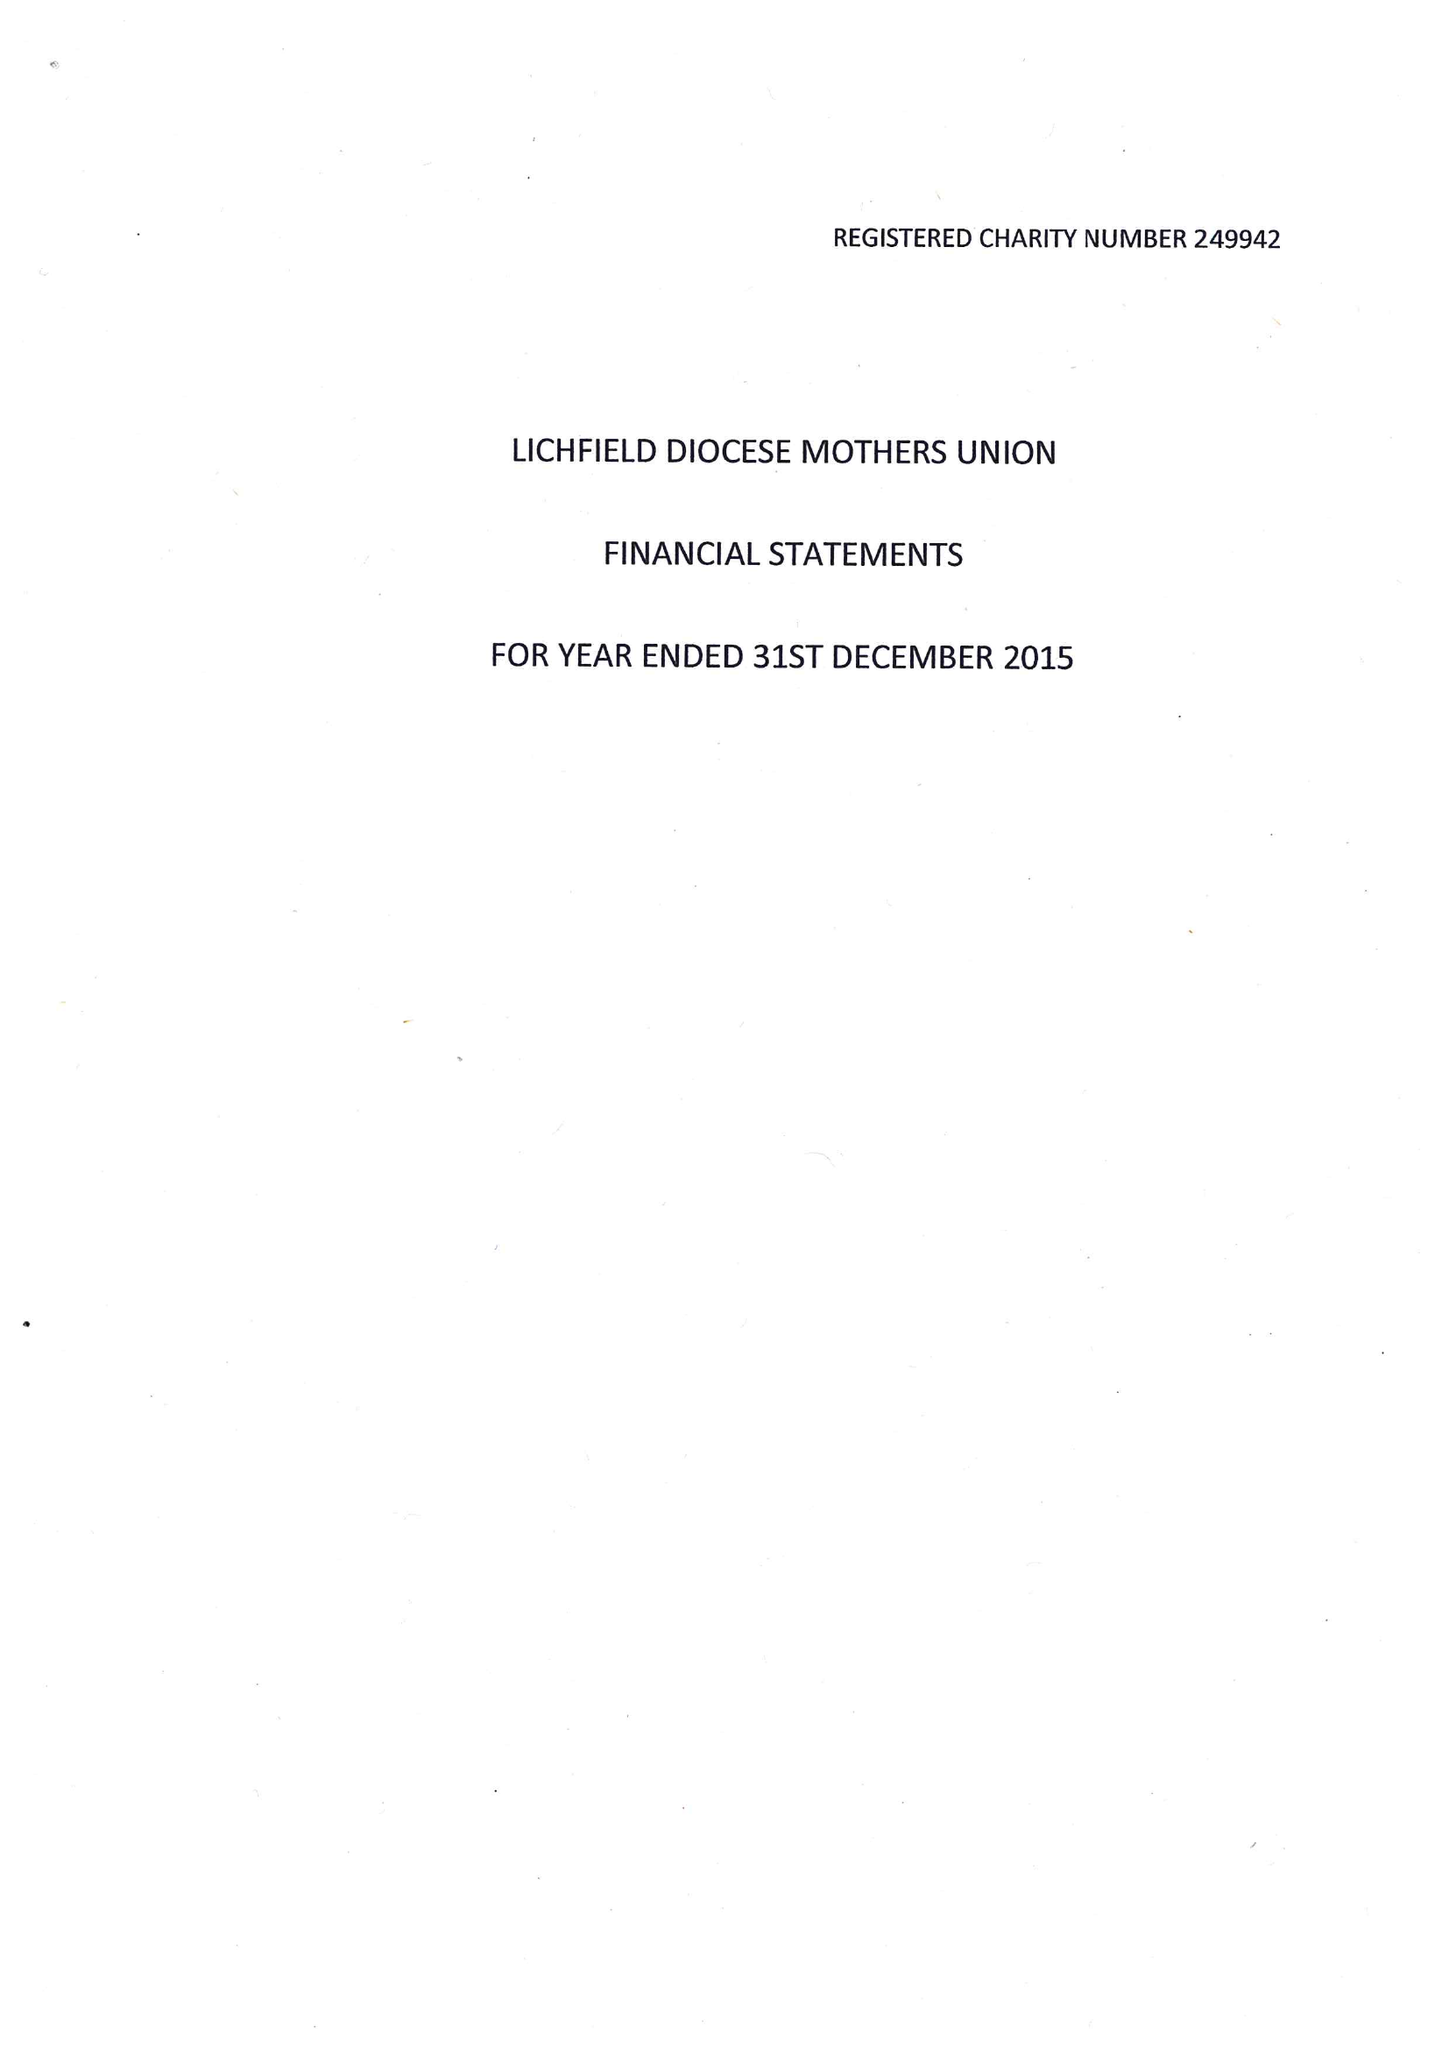What is the value for the charity_number?
Answer the question using a single word or phrase. 249942 